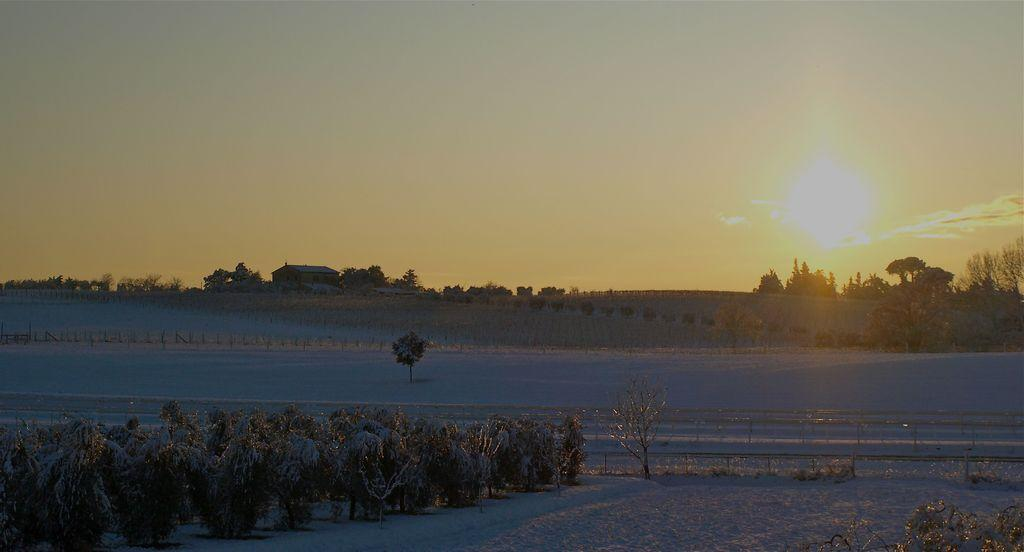What type of vegetation can be seen in the image? There are trees in the image. What is covering the ground in the image? There is snow in the image. What type of barrier is present in the image? There is a fence in the image. What type of structures can be seen in the image? There are buildings in the image. What is visible at the top of the image? The sky is visible at the top of the image. What type of bird can be seen starting its journey in the image? There are no birds or journeys present in the image. 